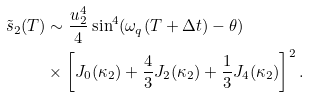<formula> <loc_0><loc_0><loc_500><loc_500>\tilde { s } _ { 2 } ( T ) & \sim \frac { u _ { 2 } ^ { 4 } } { 4 } \sin ^ { 4 } ( \omega _ { q } ( T + \Delta t ) - \theta ) \\ & \times \left [ J _ { 0 } ( \kappa _ { 2 } ) + \frac { 4 } { 3 } J _ { 2 } ( \kappa _ { 2 } ) + \frac { 1 } { 3 } J _ { 4 } ( \kappa _ { 2 } ) \right ] ^ { 2 } .</formula> 